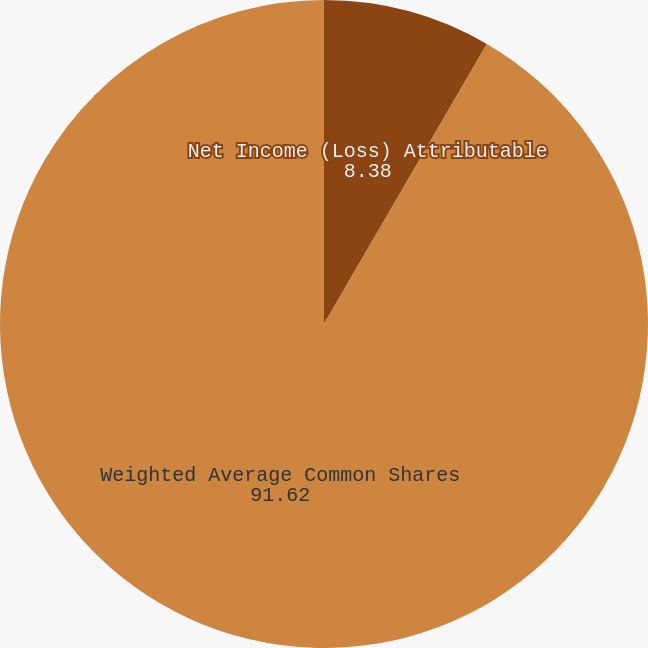<chart> <loc_0><loc_0><loc_500><loc_500><pie_chart><fcel>Income from Continuing<fcel>Net Income (Loss) Attributable<fcel>Weighted Average Common Shares<nl><fcel>0.0%<fcel>8.38%<fcel>91.62%<nl></chart> 